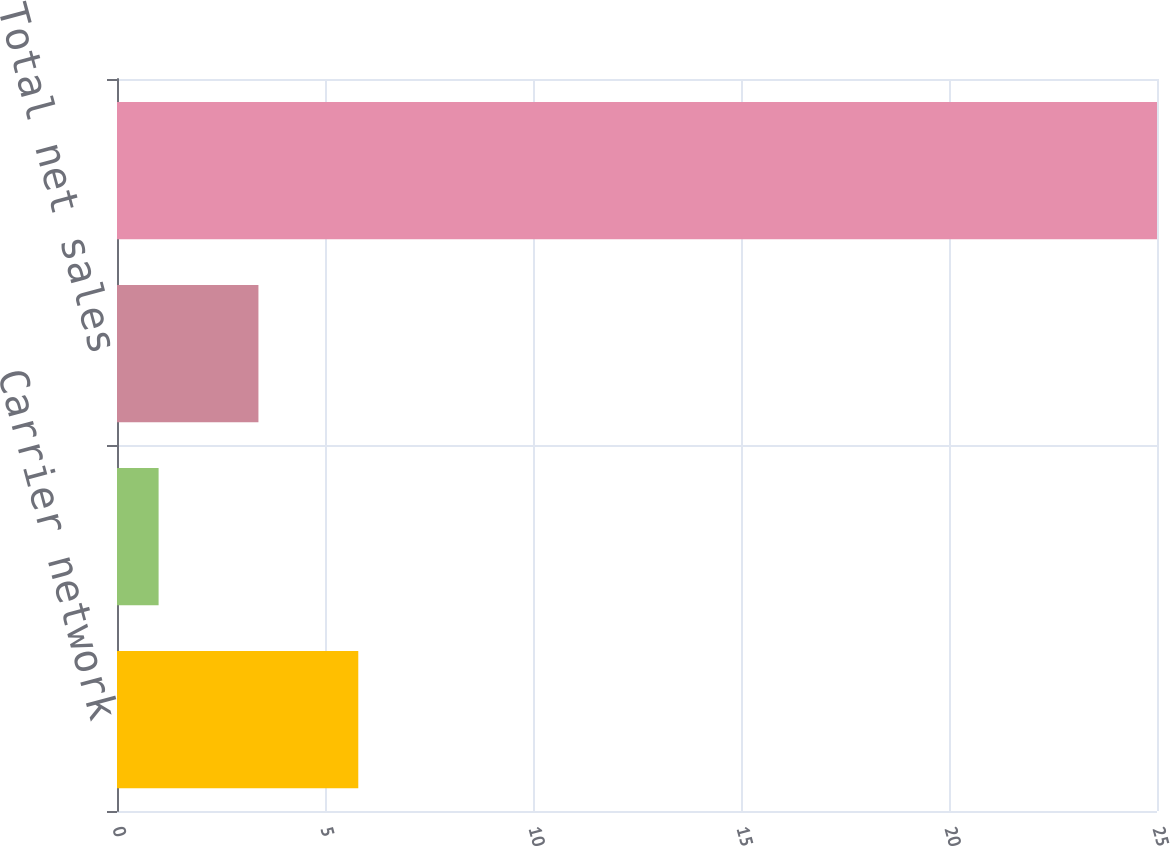Convert chart to OTSL. <chart><loc_0><loc_0><loc_500><loc_500><bar_chart><fcel>Carrier network<fcel>Enterprise network<fcel>Total net sales<fcel>Net income<nl><fcel>5.8<fcel>1<fcel>3.4<fcel>25<nl></chart> 